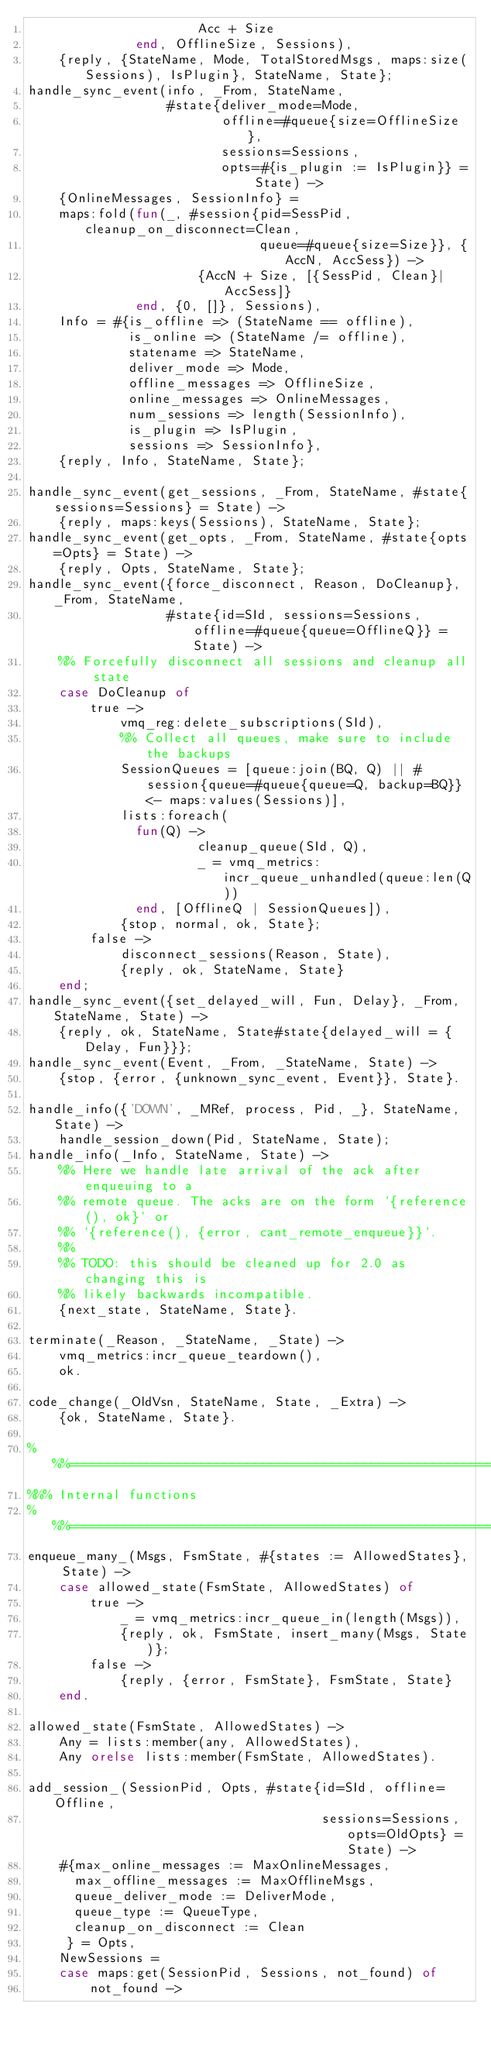Convert code to text. <code><loc_0><loc_0><loc_500><loc_500><_Erlang_>                      Acc + Size
              end, OfflineSize, Sessions),
    {reply, {StateName, Mode, TotalStoredMsgs, maps:size(Sessions), IsPlugin}, StateName, State};
handle_sync_event(info, _From, StateName,
                  #state{deliver_mode=Mode,
                         offline=#queue{size=OfflineSize},
                         sessions=Sessions,
                         opts=#{is_plugin := IsPlugin}} = State) ->
    {OnlineMessages, SessionInfo} =
    maps:fold(fun(_, #session{pid=SessPid, cleanup_on_disconnect=Clean,
                              queue=#queue{size=Size}}, {AccN, AccSess}) ->
                      {AccN + Size, [{SessPid, Clean}|AccSess]}
              end, {0, []}, Sessions),
    Info = #{is_offline => (StateName == offline),
             is_online => (StateName /= offline),
             statename => StateName,
             deliver_mode => Mode,
             offline_messages => OfflineSize,
             online_messages => OnlineMessages,
             num_sessions => length(SessionInfo),
             is_plugin => IsPlugin,
             sessions => SessionInfo},
    {reply, Info, StateName, State};

handle_sync_event(get_sessions, _From, StateName, #state{sessions=Sessions} = State) ->
    {reply, maps:keys(Sessions), StateName, State};
handle_sync_event(get_opts, _From, StateName, #state{opts=Opts} = State) ->
    {reply, Opts, StateName, State};
handle_sync_event({force_disconnect, Reason, DoCleanup}, _From, StateName,
                  #state{id=SId, sessions=Sessions, offline=#queue{queue=OfflineQ}} = State) ->
    %% Forcefully disconnect all sessions and cleanup all state
    case DoCleanup of
        true ->
            vmq_reg:delete_subscriptions(SId),
            %% Collect all queues, make sure to include the backups
            SessionQueues = [queue:join(BQ, Q) || #session{queue=#queue{queue=Q, backup=BQ}} <- maps:values(Sessions)],
            lists:foreach(
              fun(Q) ->
                      cleanup_queue(SId, Q),
                      _ = vmq_metrics:incr_queue_unhandled(queue:len(Q))
              end, [OfflineQ | SessionQueues]),
            {stop, normal, ok, State};
        false ->
            disconnect_sessions(Reason, State),
            {reply, ok, StateName, State}
    end;
handle_sync_event({set_delayed_will, Fun, Delay}, _From, StateName, State) ->
    {reply, ok, StateName, State#state{delayed_will = {Delay, Fun}}};
handle_sync_event(Event, _From, _StateName, State) ->
    {stop, {error, {unknown_sync_event, Event}}, State}.

handle_info({'DOWN', _MRef, process, Pid, _}, StateName, State) ->
    handle_session_down(Pid, StateName, State);
handle_info(_Info, StateName, State) ->
    %% Here we handle late arrival of the ack after enqueuing to a
    %% remote queue. The acks are on the form `{reference(), ok}` or
    %% `{reference(), {error, cant_remote_enqueue}}`.
    %%
    %% TODO: this should be cleaned up for 2.0 as changing this is
    %% likely backwards incompatible.
    {next_state, StateName, State}.

terminate(_Reason, _StateName, _State) ->
    vmq_metrics:incr_queue_teardown(),
    ok.

code_change(_OldVsn, StateName, State, _Extra) ->
    {ok, StateName, State}.

%%%===================================================================
%%% Internal functions
%%%===================================================================
enqueue_many_(Msgs, FsmState, #{states := AllowedStates}, State) ->
    case allowed_state(FsmState, AllowedStates) of
        true ->
            _ = vmq_metrics:incr_queue_in(length(Msgs)),
            {reply, ok, FsmState, insert_many(Msgs, State)};
        false ->
            {reply, {error, FsmState}, FsmState, State}
    end.

allowed_state(FsmState, AllowedStates) ->
    Any = lists:member(any, AllowedStates),
    Any orelse lists:member(FsmState, AllowedStates).

add_session_(SessionPid, Opts, #state{id=SId, offline=Offline,
                                      sessions=Sessions, opts=OldOpts} = State) ->
    #{max_online_messages := MaxOnlineMessages,
      max_offline_messages := MaxOfflineMsgs,
      queue_deliver_mode := DeliverMode,
      queue_type := QueueType,
      cleanup_on_disconnect := Clean
     } = Opts,
    NewSessions =
    case maps:get(SessionPid, Sessions, not_found) of
        not_found -></code> 